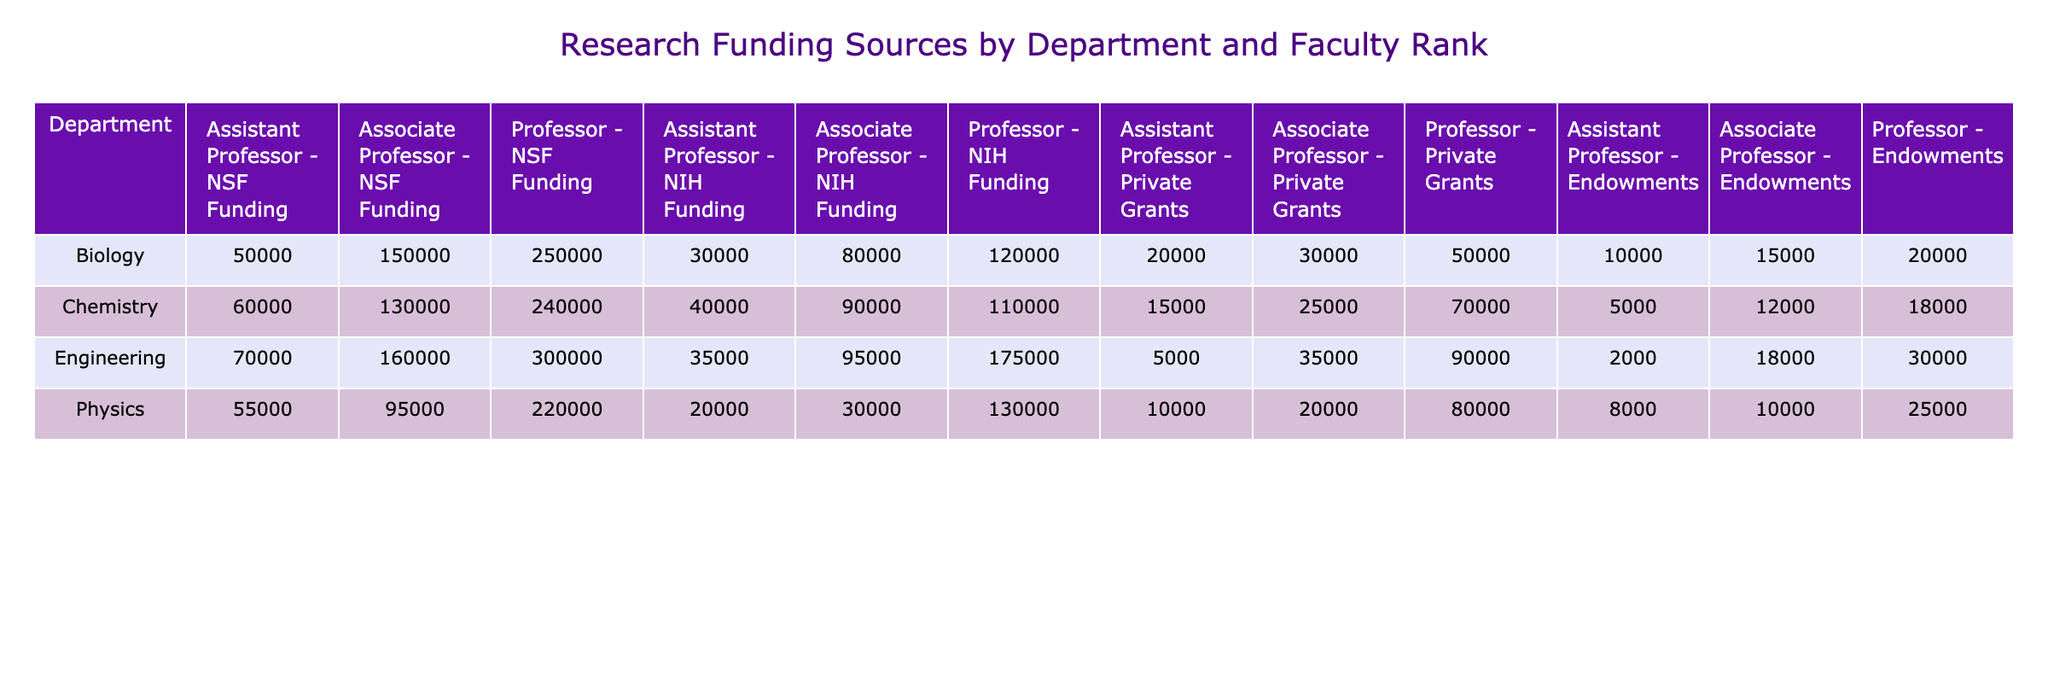What is the total NSF Funding for the Engineering department? Summing up the NSF Funding values for Engineering across all faculty ranks: 70000 (Assistant Professor) + 160000 (Associate Professor) + 300000 (Professor) = 530000
Answer: 530000 Which department has the highest NIH Funding for Professors? The NIH Funding for Professors is as follows: Biology - 120000, Chemistry - 110000, Physics - 130000, Engineering - 175000. The highest value is found in the Engineering department at 175000.
Answer: Engineering What is the average total funding (NSF, NIH, Private Grants, Endowments) for Associate Professors in the Chemistry department? For Chemistry Associate Professors, the fund amounts are NSF (130000), NIH (90000), Private Grants (25000), Endowments (12000). Adding these gives a total of 130000 + 90000 + 25000 + 12000 = 306000. To find the average, we divide by 4 (number of funding categories), which equals 76500.
Answer: 76500 Is the Private Grants funding for Physics Professors less than that for Biology Professors? Comparing the values: Private Grants for Physics Professors is 80000 and for Biology Professors it is 50000. Since 80000 is greater than 50000, the statement is false.
Answer: No What is the total Endowments for all Assistant Professors? Summing the Endowments for Assistant Professors: 10000 (Biology) + 5000 (Chemistry) + 8000 (Physics) + 2000 (Engineering) = 25000.
Answer: 25000 Which department has the lowest total funding for the NSF category across all Faculty Ranks? Calculating total NSF Funding for each department: Biology (50000 + 150000 + 250000 = 450000), Chemistry (60000 + 130000 + 240000 = 430000), Physics (55000 + 95000 + 220000 = 370000), Engineering (70000 + 160000 + 300000 = 530000). The lowest total is for the Physics department at 370000.
Answer: Physics How much more did the highest-ranked Professor in Engineering receive in Endowments compared to the highest-ranked Professor in Chemistry? Engineering Professor received 30000 in Endowments and Chemistry Professor received 18000. The difference is 30000 - 18000 = 12000.
Answer: 12000 Do Assistant Professors in Biology receive more in total funding than those in Physics? Total funding for Biology Assistant Professors is: NSF (50000) + NIH (30000) + Private Grants (20000) + Endowments (10000) = 110000. For Physics Assistant Professors, the total is: NSF (55000) + NIH (20000) + Private Grants (10000) + Endowments (8000) = 93000. Since 110000 is greater than 93000, the statement is true.
Answer: Yes 